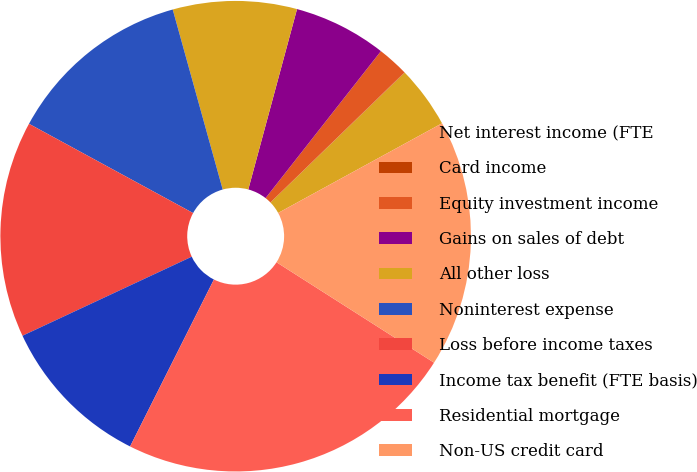<chart> <loc_0><loc_0><loc_500><loc_500><pie_chart><fcel>Net interest income (FTE<fcel>Card income<fcel>Equity investment income<fcel>Gains on sales of debt<fcel>All other loss<fcel>Noninterest expense<fcel>Loss before income taxes<fcel>Income tax benefit (FTE basis)<fcel>Residential mortgage<fcel>Non-US credit card<nl><fcel>4.27%<fcel>0.02%<fcel>2.15%<fcel>6.39%<fcel>8.51%<fcel>12.76%<fcel>14.88%<fcel>10.64%<fcel>23.37%<fcel>17.0%<nl></chart> 